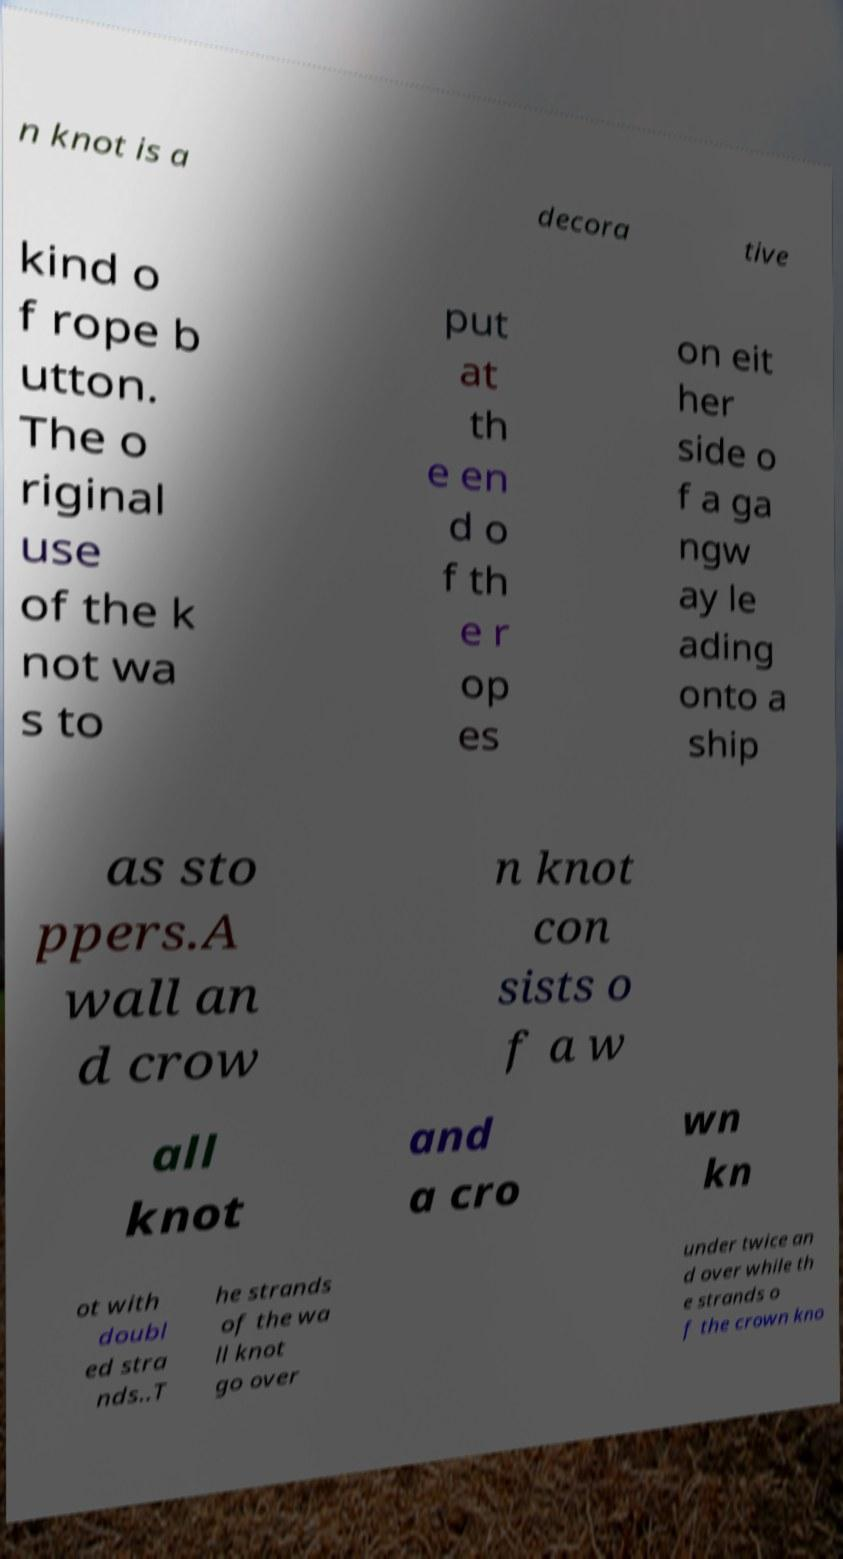Can you accurately transcribe the text from the provided image for me? n knot is a decora tive kind o f rope b utton. The o riginal use of the k not wa s to put at th e en d o f th e r op es on eit her side o f a ga ngw ay le ading onto a ship as sto ppers.A wall an d crow n knot con sists o f a w all knot and a cro wn kn ot with doubl ed stra nds..T he strands of the wa ll knot go over under twice an d over while th e strands o f the crown kno 